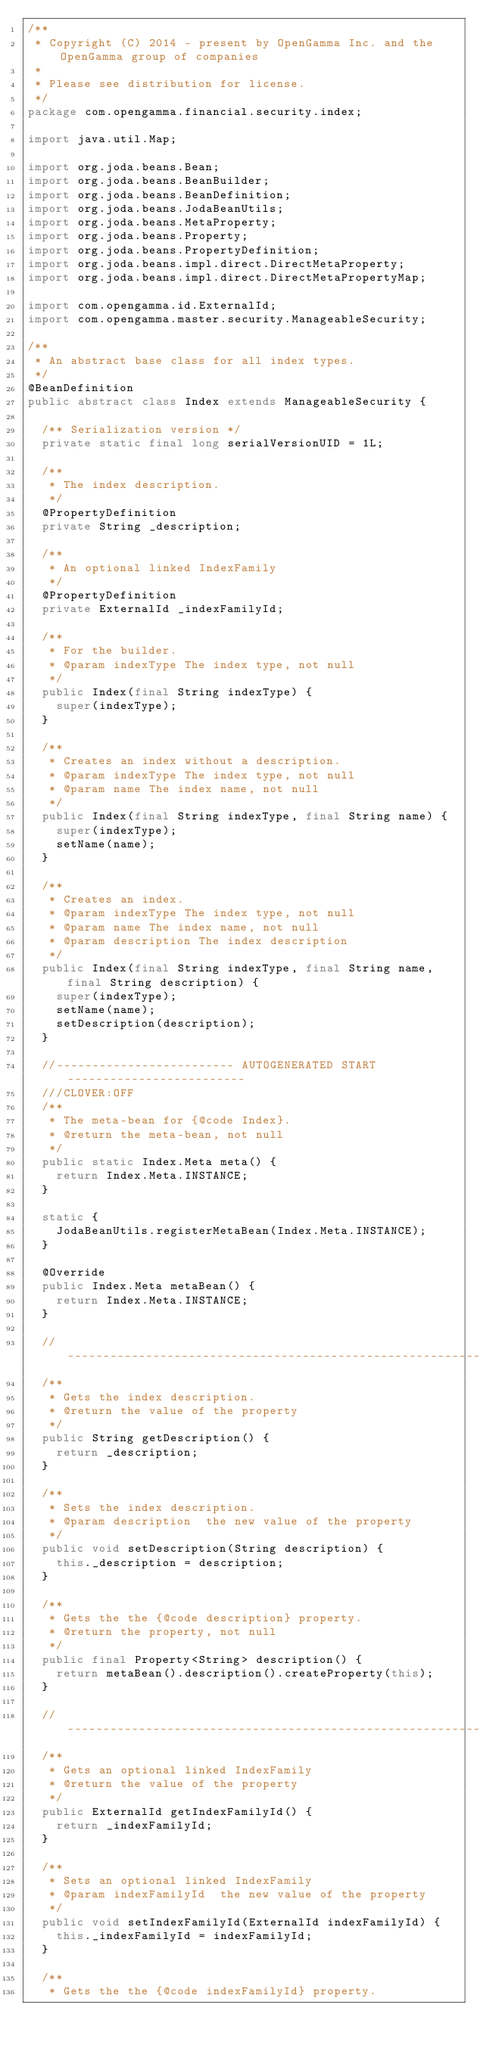<code> <loc_0><loc_0><loc_500><loc_500><_Java_>/**
 * Copyright (C) 2014 - present by OpenGamma Inc. and the OpenGamma group of companies
 * 
 * Please see distribution for license.
 */
package com.opengamma.financial.security.index;

import java.util.Map;

import org.joda.beans.Bean;
import org.joda.beans.BeanBuilder;
import org.joda.beans.BeanDefinition;
import org.joda.beans.JodaBeanUtils;
import org.joda.beans.MetaProperty;
import org.joda.beans.Property;
import org.joda.beans.PropertyDefinition;
import org.joda.beans.impl.direct.DirectMetaProperty;
import org.joda.beans.impl.direct.DirectMetaPropertyMap;

import com.opengamma.id.ExternalId;
import com.opengamma.master.security.ManageableSecurity;

/**
 * An abstract base class for all index types.
 */
@BeanDefinition
public abstract class Index extends ManageableSecurity {

  /** Serialization version */
  private static final long serialVersionUID = 1L;

  /**
   * The index description.
   */
  @PropertyDefinition
  private String _description;
  
  /**
   * An optional linked IndexFamily
   */
  @PropertyDefinition
  private ExternalId _indexFamilyId;

  /**
   * For the builder.
   * @param indexType The index type, not null
   */
  public Index(final String indexType) {
    super(indexType);
  }

  /**
   * Creates an index without a description.
   * @param indexType The index type, not null
   * @param name The index name, not null
   */
  public Index(final String indexType, final String name) {
    super(indexType);
    setName(name);
  }

  /**
   * Creates an index.
   * @param indexType The index type, not null
   * @param name The index name, not null
   * @param description The index description
   */
  public Index(final String indexType, final String name, final String description) {
    super(indexType);
    setName(name);
    setDescription(description);
  }

  //------------------------- AUTOGENERATED START -------------------------
  ///CLOVER:OFF
  /**
   * The meta-bean for {@code Index}.
   * @return the meta-bean, not null
   */
  public static Index.Meta meta() {
    return Index.Meta.INSTANCE;
  }

  static {
    JodaBeanUtils.registerMetaBean(Index.Meta.INSTANCE);
  }

  @Override
  public Index.Meta metaBean() {
    return Index.Meta.INSTANCE;
  }

  //-----------------------------------------------------------------------
  /**
   * Gets the index description.
   * @return the value of the property
   */
  public String getDescription() {
    return _description;
  }

  /**
   * Sets the index description.
   * @param description  the new value of the property
   */
  public void setDescription(String description) {
    this._description = description;
  }

  /**
   * Gets the the {@code description} property.
   * @return the property, not null
   */
  public final Property<String> description() {
    return metaBean().description().createProperty(this);
  }

  //-----------------------------------------------------------------------
  /**
   * Gets an optional linked IndexFamily
   * @return the value of the property
   */
  public ExternalId getIndexFamilyId() {
    return _indexFamilyId;
  }

  /**
   * Sets an optional linked IndexFamily
   * @param indexFamilyId  the new value of the property
   */
  public void setIndexFamilyId(ExternalId indexFamilyId) {
    this._indexFamilyId = indexFamilyId;
  }

  /**
   * Gets the the {@code indexFamilyId} property.</code> 